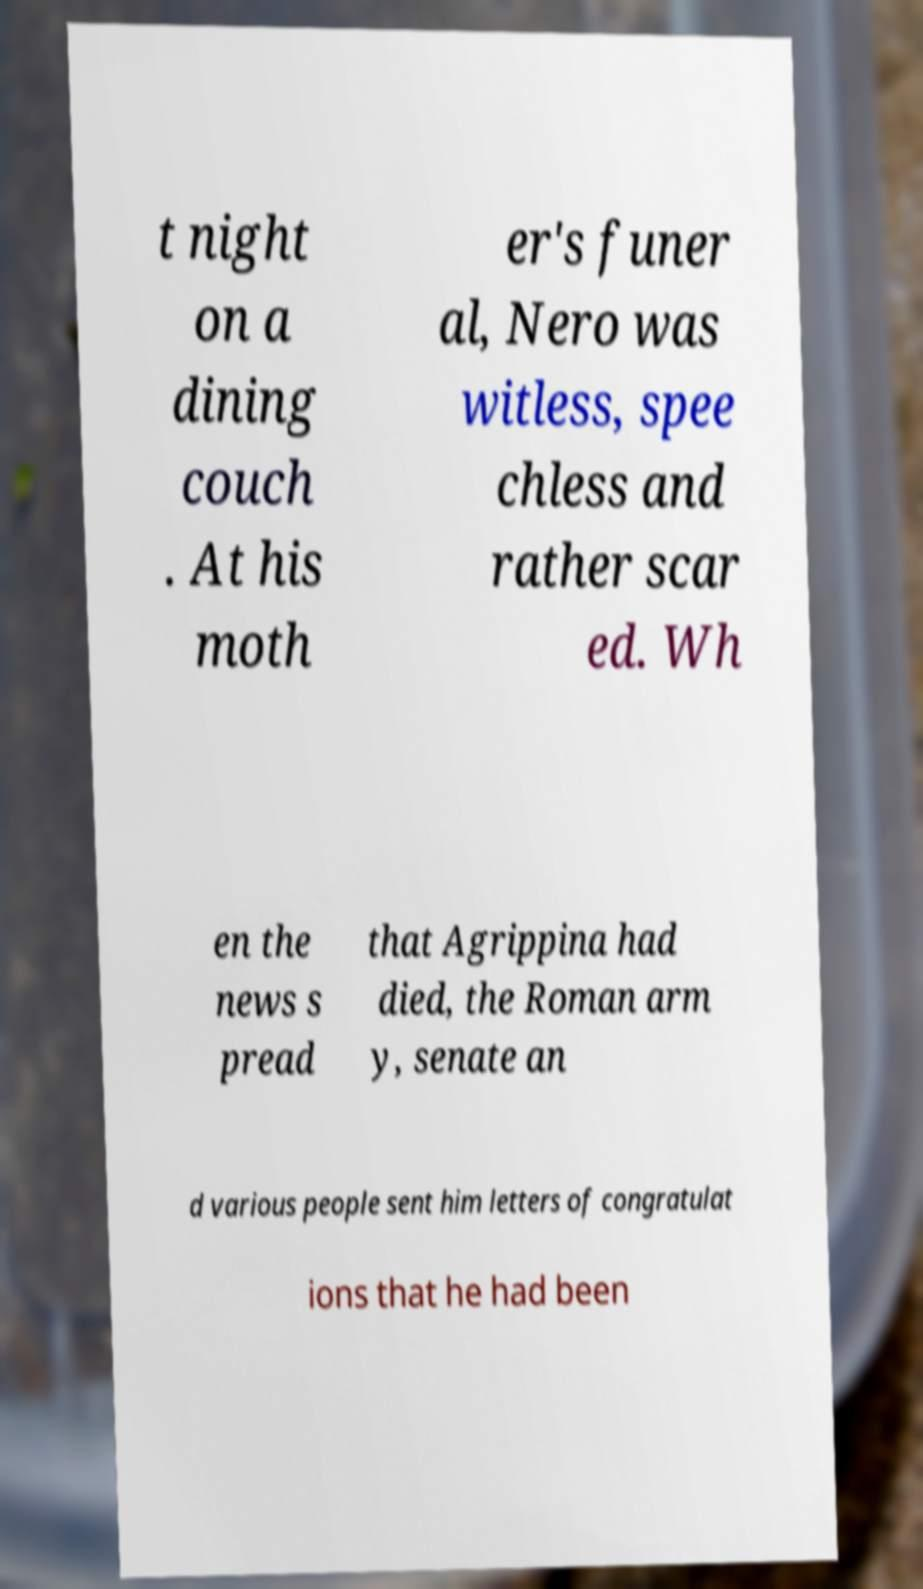Can you read and provide the text displayed in the image?This photo seems to have some interesting text. Can you extract and type it out for me? t night on a dining couch . At his moth er's funer al, Nero was witless, spee chless and rather scar ed. Wh en the news s pread that Agrippina had died, the Roman arm y, senate an d various people sent him letters of congratulat ions that he had been 